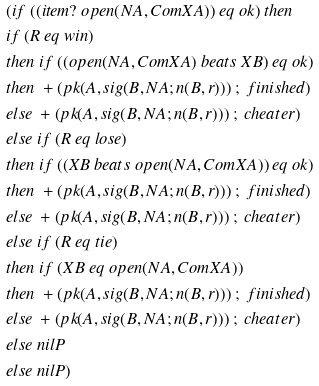Convert formula to latex. <formula><loc_0><loc_0><loc_500><loc_500>& ( i f \ ( ( i t e m ? \ o p e n ( N A , C o m X A ) ) \ e q \ o k ) \ t h e n \\ & i f \ ( R \ e q \ w i n ) \\ & t h e n \ i f \ ( ( o p e n ( N A , C o m X A ) \ b e a t s \ X B ) \ e q \ o k ) \\ & t h e n \ + ( p k ( A , s i g ( B , N A ; n ( B , r ) ) ) \ ; \ f i n i s h e d ) \\ & e l s e \ + ( p k ( A , s i g ( B , N A ; n ( B , r ) ) ) \ ; \ c h e a t e r ) \\ & e l s e \ i f \ ( R \ e q \ l o s e ) \\ & t h e n \ i f \ ( ( X B \ b e a t s \ o p e n ( N A , C o m X A ) ) \ e q \ o k ) \\ & t h e n \ + ( p k ( A , s i g ( B , N A ; n ( B , r ) ) ) \ ; \ f i n i s h e d ) \\ & e l s e \ + ( p k ( A , s i g ( B , N A ; n ( B , r ) ) ) \ ; \ c h e a t e r ) \\ & e l s e \ i f \ ( R \ e q \ t i e ) \\ & t h e n \ i f \ ( X B \ e q \ o p e n ( N A , C o m X A ) ) \\ & t h e n \ + ( p k ( A , s i g ( B , N A ; n ( B , r ) ) ) \ ; \ f i n i s h e d ) \\ & e l s e \ + ( p k ( A , s i g ( B , N A ; n ( B , r ) ) ) \ ; \ c h e a t e r ) \\ & e l s e \ n i l P \\ & e l s e \ n i l P )</formula> 